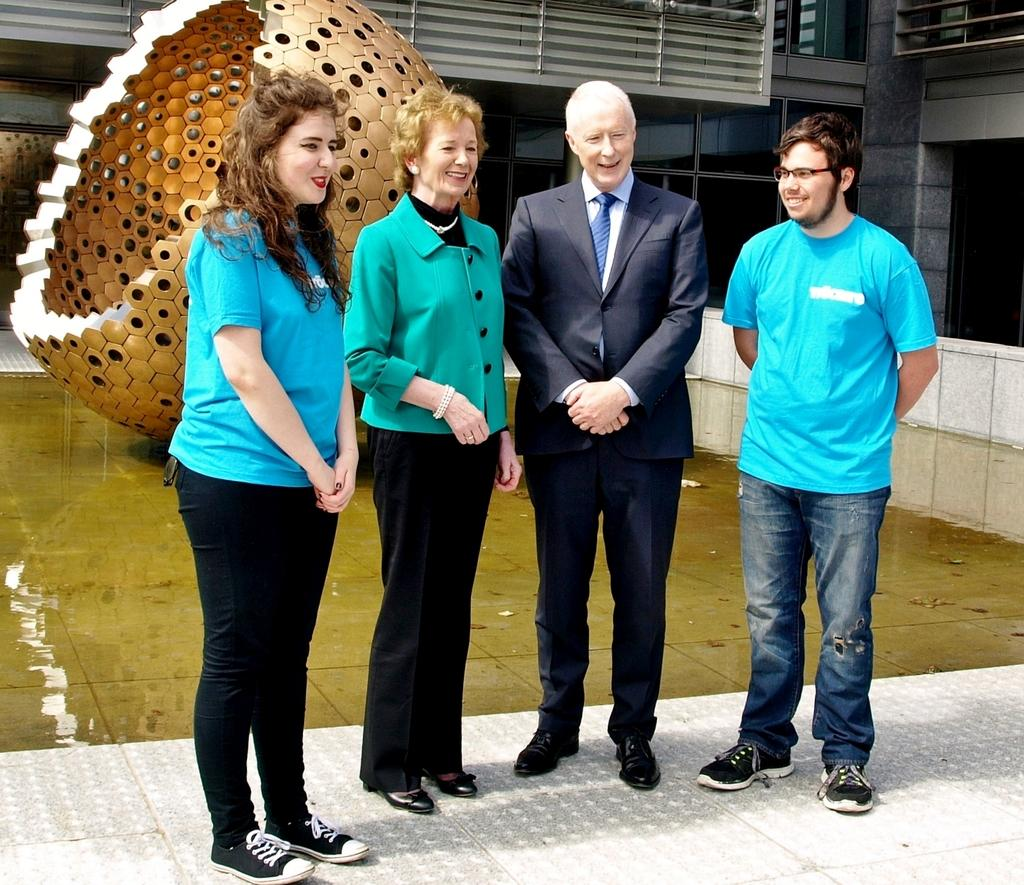Who or what can be seen in the image? There are people in the image. What is on the ground in the image? There is water on the ground in the image. What shape is the object in the image? The object in the image is spherical shaped. What type of structure is visible in the image? There is a building in the image. What type of learning is taking place in the image? There is no indication of any learning taking place in the image. What attraction is present in the image? There is no specific attraction mentioned or visible in the image. 